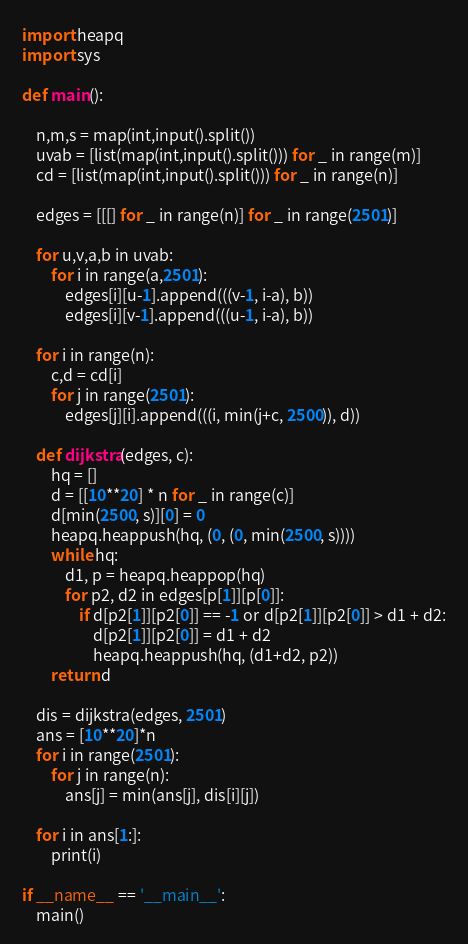<code> <loc_0><loc_0><loc_500><loc_500><_Python_>import heapq
import sys

def main():

    n,m,s = map(int,input().split())
    uvab = [list(map(int,input().split())) for _ in range(m)]
    cd = [list(map(int,input().split())) for _ in range(n)]

    edges = [[[] for _ in range(n)] for _ in range(2501)]

    for u,v,a,b in uvab:
        for i in range(a,2501):
            edges[i][u-1].append(((v-1, i-a), b))
            edges[i][v-1].append(((u-1, i-a), b))

    for i in range(n):
        c,d = cd[i]
        for j in range(2501):
            edges[j][i].append(((i, min(j+c, 2500)), d))

    def dijkstra(edges, c):
        hq = []
        d = [[10**20] * n for _ in range(c)]
        d[min(2500, s)][0] = 0
        heapq.heappush(hq, (0, (0, min(2500, s))))
        while hq:
            d1, p = heapq.heappop(hq)
            for p2, d2 in edges[p[1]][p[0]]:
                if d[p2[1]][p2[0]] == -1 or d[p2[1]][p2[0]] > d1 + d2:
                    d[p2[1]][p2[0]] = d1 + d2
                    heapq.heappush(hq, (d1+d2, p2))
        return d

    dis = dijkstra(edges, 2501)
    ans = [10**20]*n
    for i in range(2501):
        for j in range(n):
            ans[j] = min(ans[j], dis[i][j])

    for i in ans[1:]:
        print(i)

if __name__ == '__main__':
    main()
</code> 